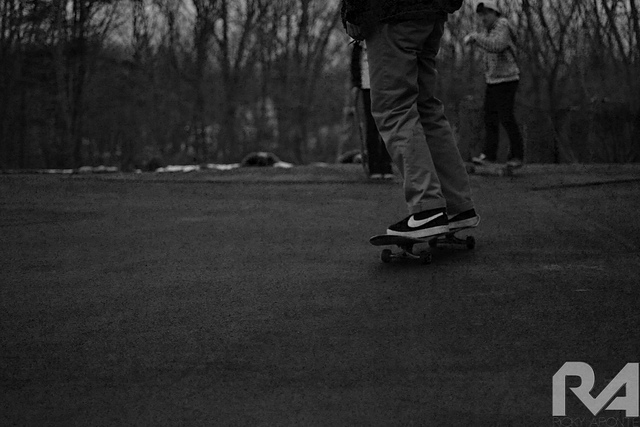<image>What color are the wheels? I am not sure. However, the wheels can be black or dark. What color are the wheels? The wheels are most likely black. 